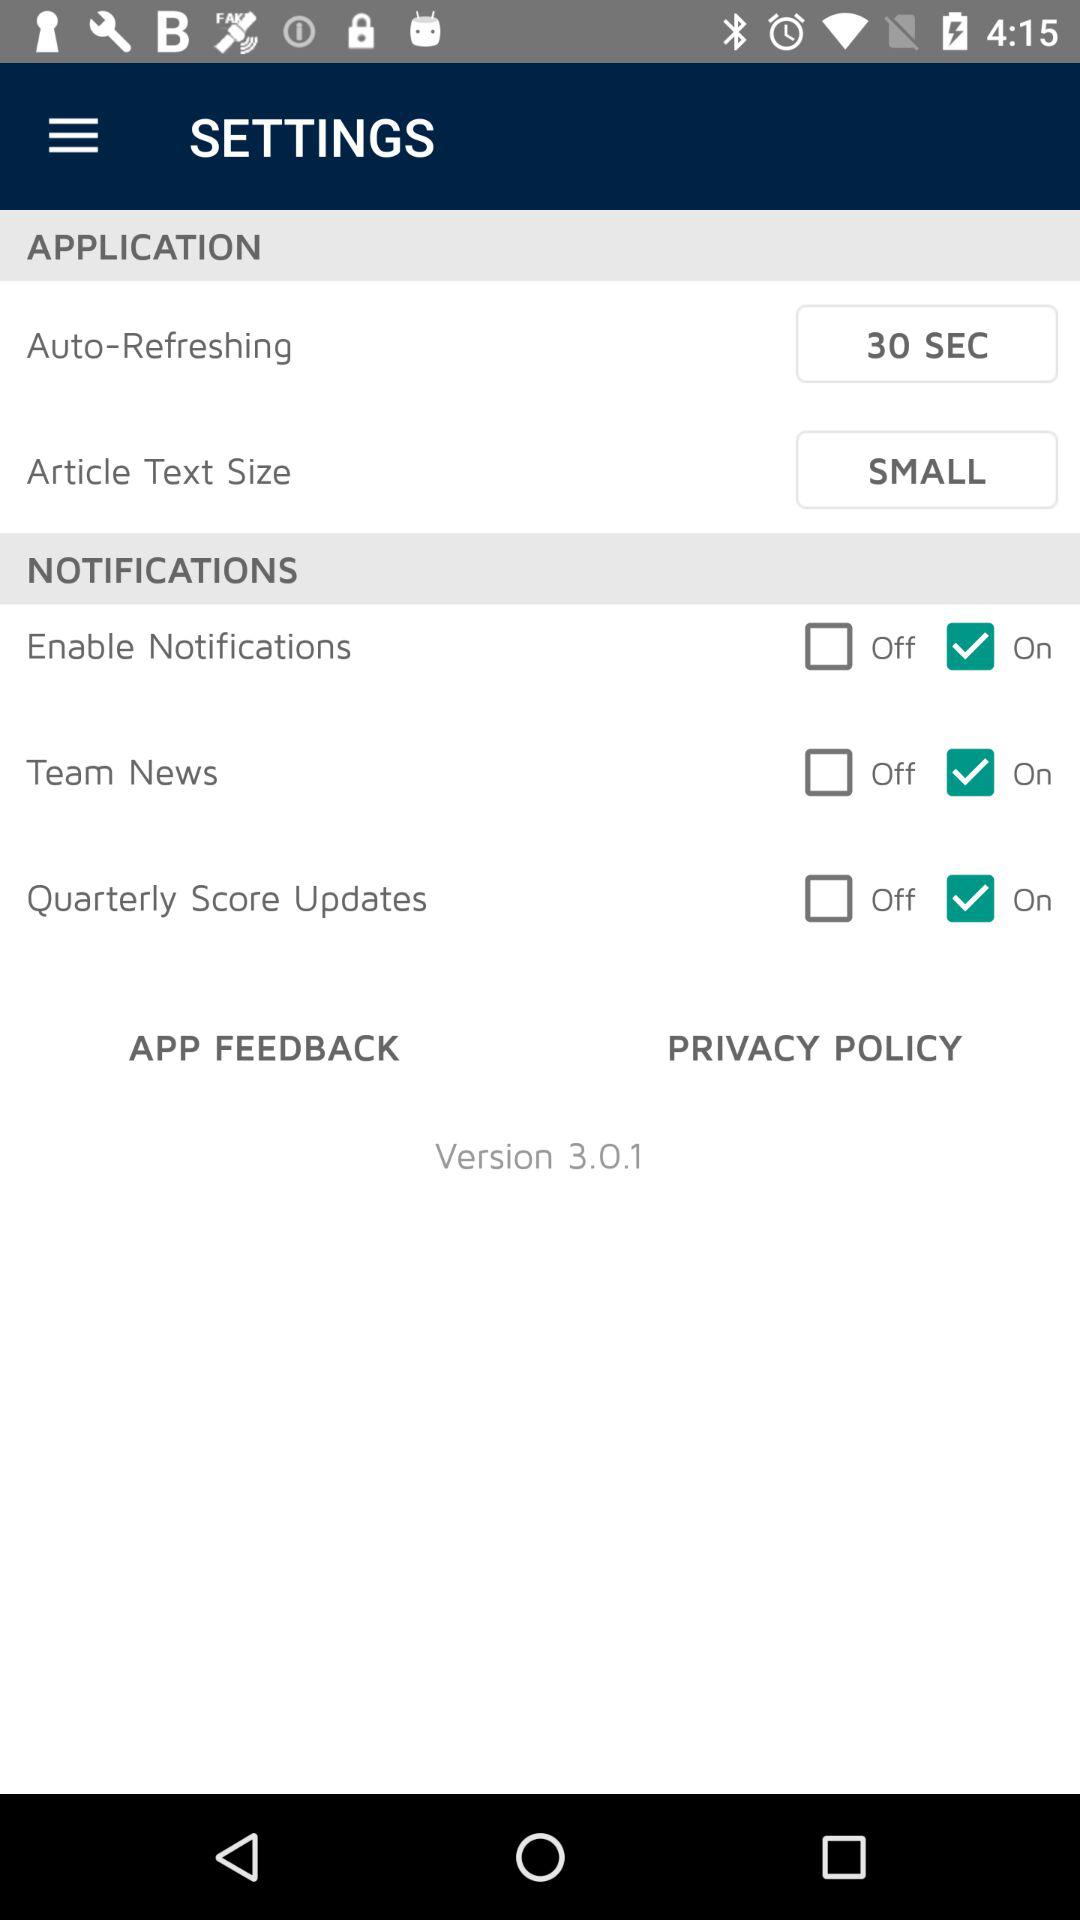What is the version of the application? The version of the application is 3.0.1. 